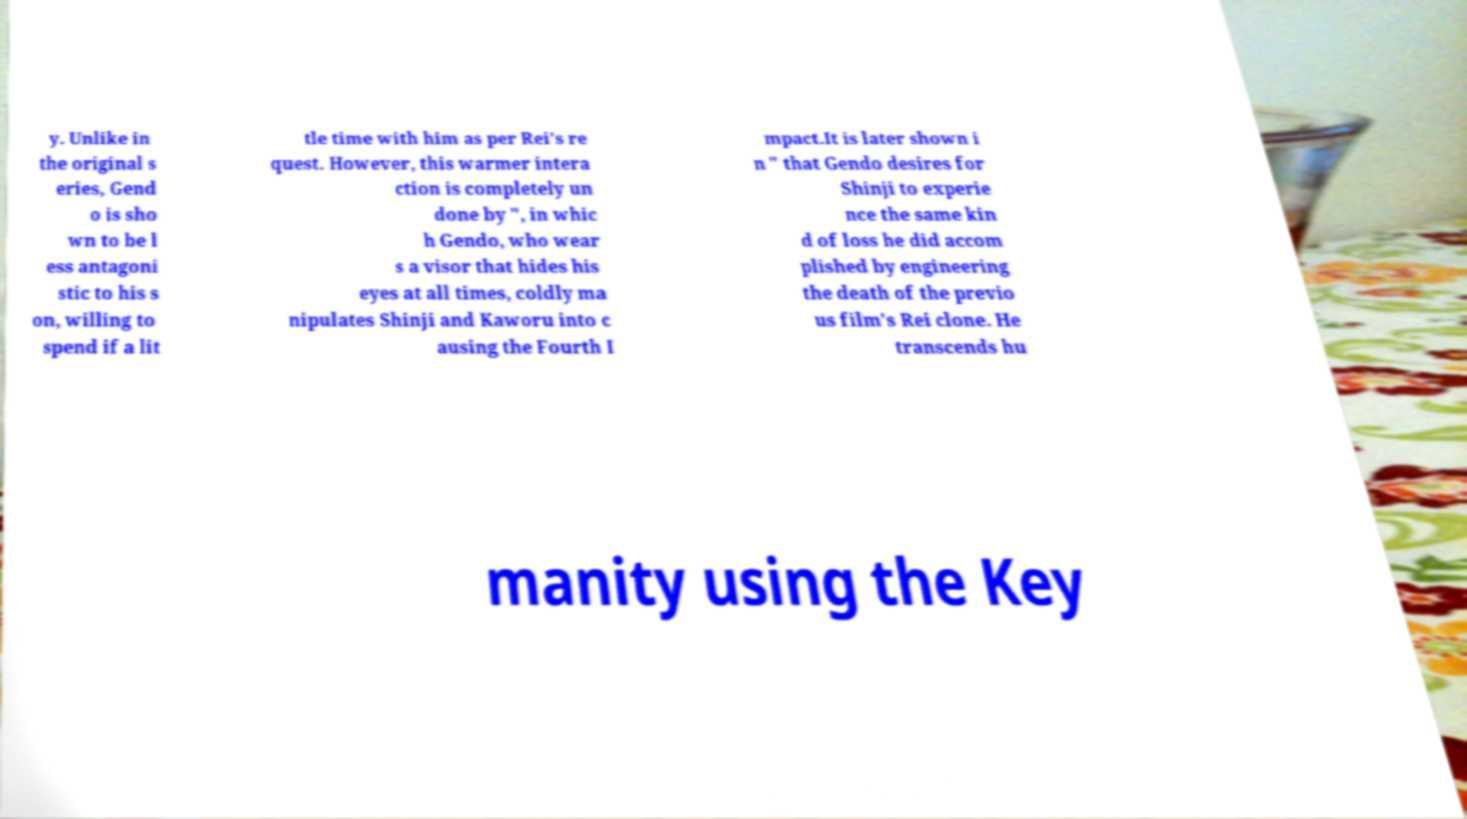For documentation purposes, I need the text within this image transcribed. Could you provide that? y. Unlike in the original s eries, Gend o is sho wn to be l ess antagoni stic to his s on, willing to spend if a lit tle time with him as per Rei's re quest. However, this warmer intera ction is completely un done by ", in whic h Gendo, who wear s a visor that hides his eyes at all times, coldly ma nipulates Shinji and Kaworu into c ausing the Fourth I mpact.It is later shown i n " that Gendo desires for Shinji to experie nce the same kin d of loss he did accom plished by engineering the death of the previo us film's Rei clone. He transcends hu manity using the Key 